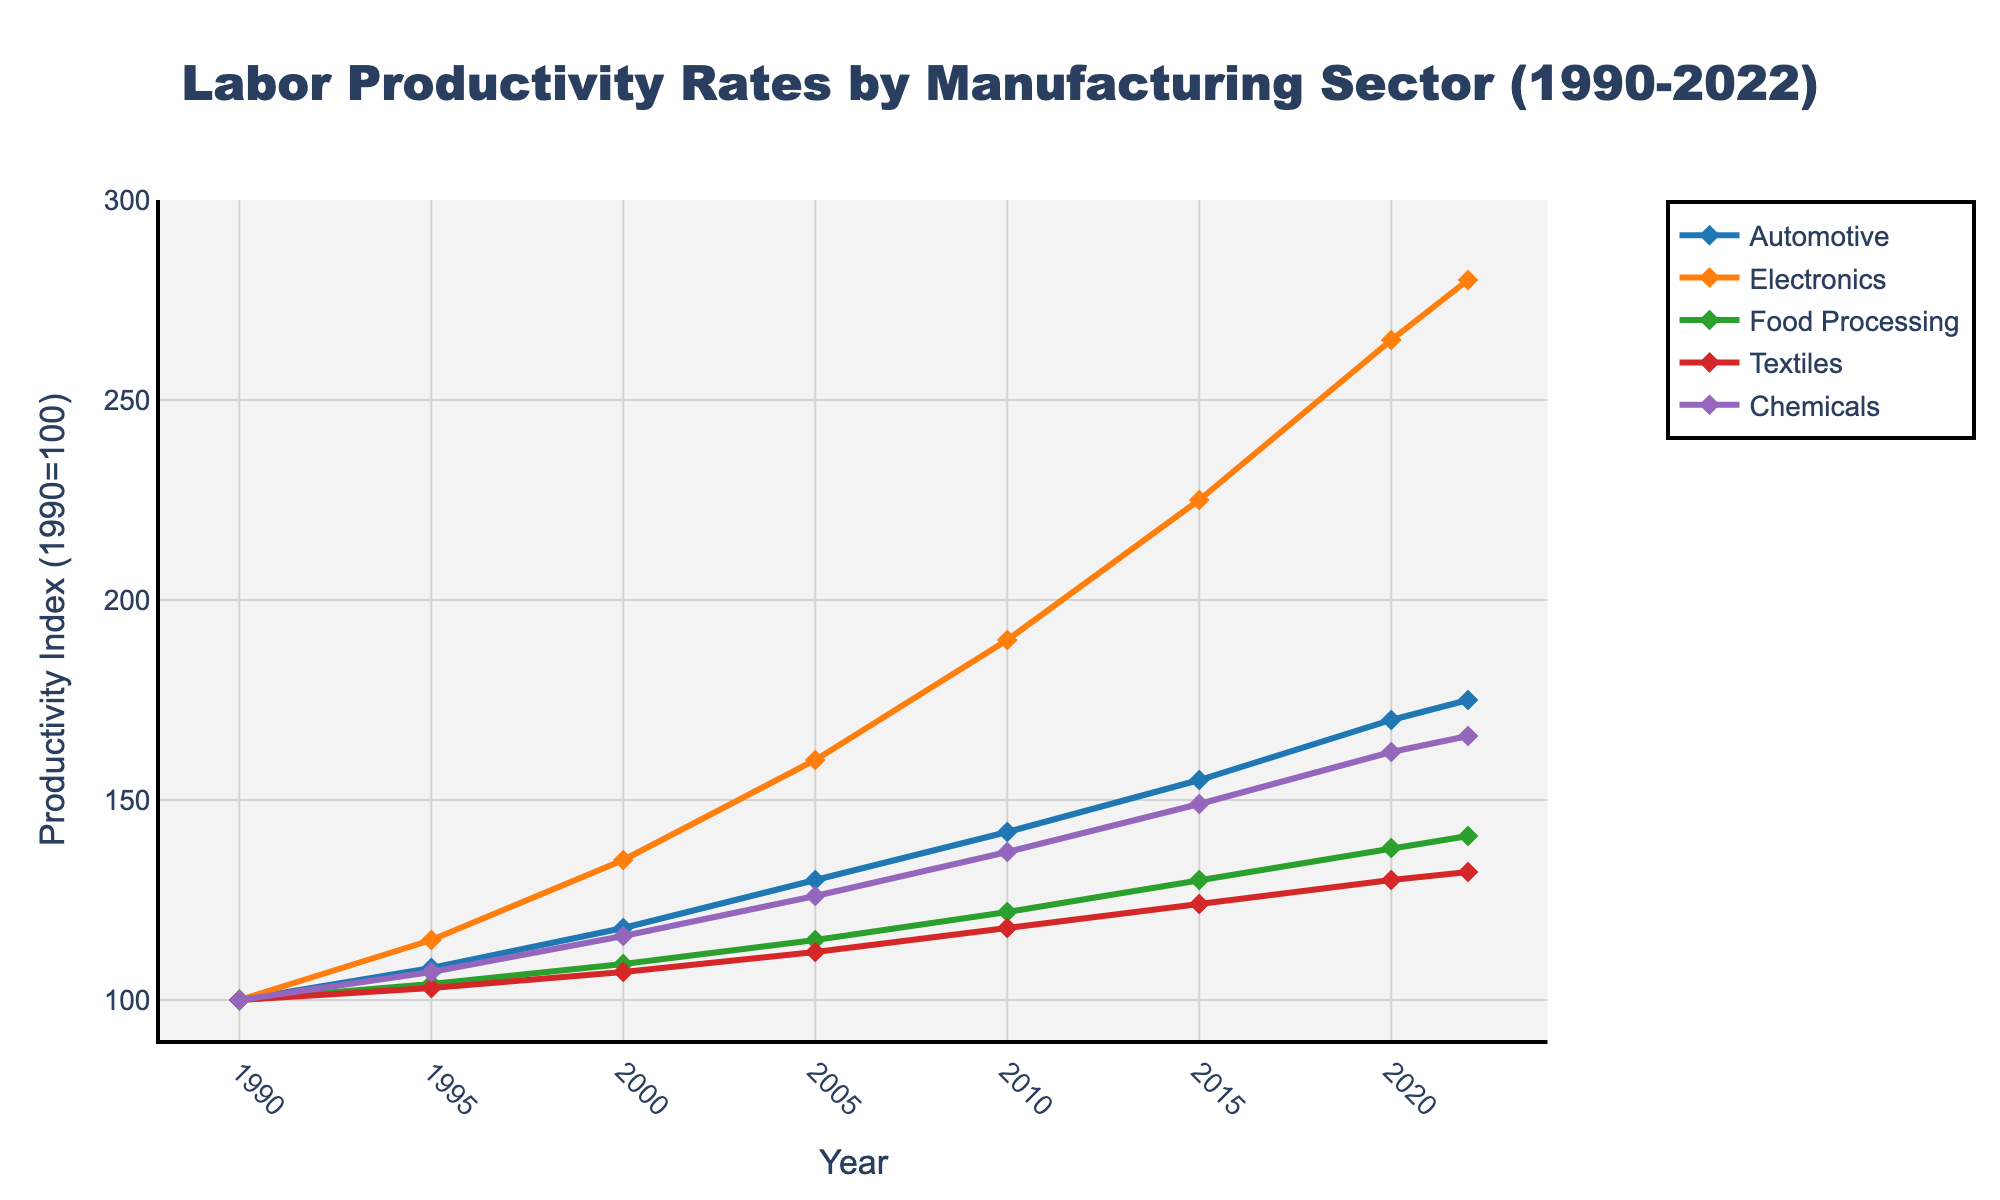What is the highest productivity rate achieved by the Electronics sector? Look at the line corresponding to the Electronics sector and identify its highest point on the y-axis. The highest value is at the year 2022, reaching 280.
Answer: 280 How has the productivity rate in the Automotive sector changed from 1990 to 2022? Observe the starting point (1990) and the endpoint (2022) on the Automotive line. The value rises from 100 in 1990 to 175 in 2022.
Answer: Increased by 75 Which sector showed the most significant increase in productivity rates from 1990 to 2022? Compare the end values (2022) with the start values (1990) for all sectors. The Electronics sector increased the most from 100 to 280.
Answer: Electronics Which sector had the lowest productivity rate in 2022? Identify the endpoint for all sectors in 2022. The Textiles sector has the lowest value at 132.
Answer: Textiles By how much did the Chemicals sector’s productivity rate increase from 2010 to 2022? Find the Chemicals productivity rates at 2010 (137) and 2022 (166), then subtract the former from the latter. 166 - 137 = 29.
Answer: 29 What was the productivity rate for Food Processing in 2005, and how does it compare to 2022? Identify the values for Food Processing in 2005 (115) and 2022 (141), then compare them by calculating the difference. 141 - 115 = 26.
Answer: Increased by 26 Which two sectors’ productivity rates appear to have grown the most similar over the years? Examine the trends and slopes for each sector over the years; Automotive and Chemicals have relatively parallel increasing trends.
Answer: Automotive and Chemicals For which sector did productivity rates rise the fastest between 2000 and 2010? Determine the change in productivity rates from 2000 to 2010 for each sector and compare. Electronics rose from 135 to 190, the steepest increase (55).
Answer: Electronics Compare the growth rates of Textiles and Food Processing sectors between 1990 and 2022. Who had a higher overall growth? Find the difference for both sectors from 1990 to 2022: Textiles (132 - 100 = 32) and Food Processing (141 - 100 = 41). Food Processing had higher overall growth.
Answer: Food Processing Which year did Automotive productivity first surpass 150? Trace the Automotive line to the first year where the productivity rate crosses 150. This occurs in 2015.
Answer: 2015 